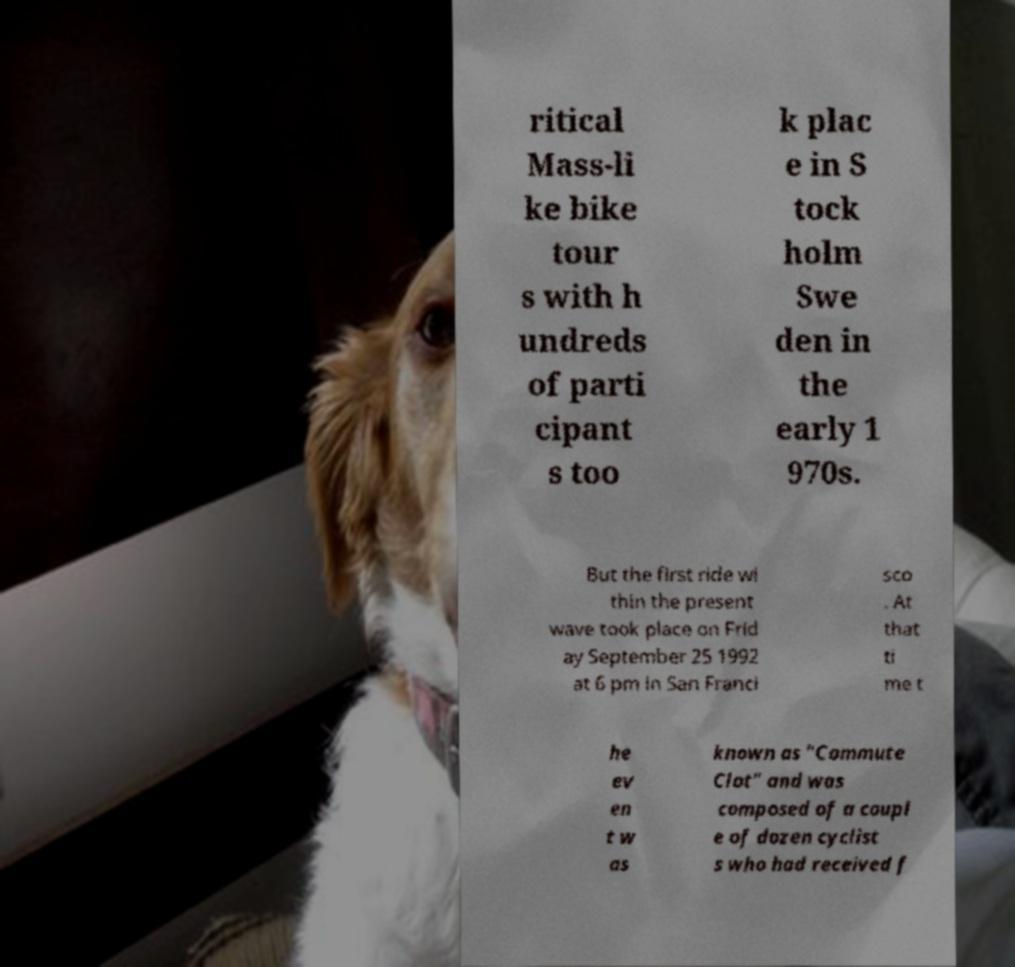Please read and relay the text visible in this image. What does it say? ritical Mass-li ke bike tour s with h undreds of parti cipant s too k plac e in S tock holm Swe den in the early 1 970s. But the first ride wi thin the present wave took place on Frid ay September 25 1992 at 6 pm in San Franci sco . At that ti me t he ev en t w as known as "Commute Clot" and was composed of a coupl e of dozen cyclist s who had received f 